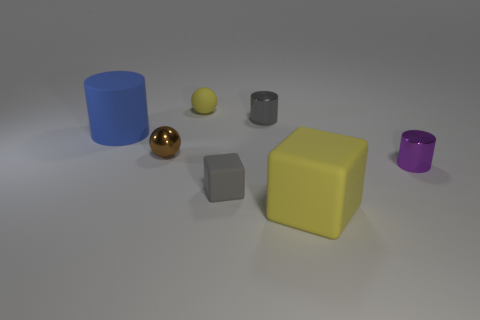There is a big thing that is the same color as the rubber sphere; what material is it?
Your answer should be compact. Rubber. There is a purple cylinder that is the same size as the brown ball; what material is it?
Your answer should be compact. Metal. Is there a large matte thing of the same color as the metal ball?
Offer a very short reply. No. There is a small thing that is both to the left of the purple thing and in front of the brown metallic thing; what shape is it?
Your answer should be very brief. Cube. How many gray cubes are the same material as the small purple object?
Offer a terse response. 0. Is the number of gray shiny cylinders that are on the left side of the brown object less than the number of large objects behind the big blue cylinder?
Provide a short and direct response. No. The small sphere in front of the sphere behind the small gray thing right of the gray cube is made of what material?
Offer a terse response. Metal. There is a matte thing that is both behind the large yellow block and in front of the purple metal cylinder; what size is it?
Your answer should be very brief. Small. How many cubes are either cyan shiny things or purple objects?
Give a very brief answer. 0. What is the color of the metal sphere that is the same size as the gray rubber thing?
Keep it short and to the point. Brown. 